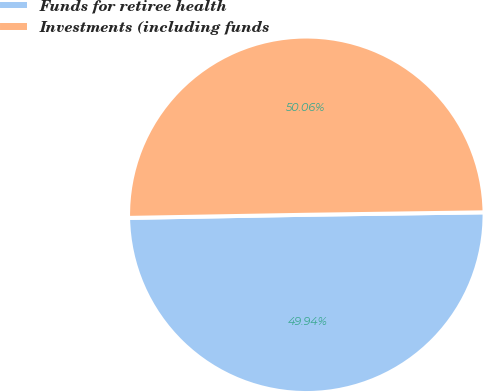<chart> <loc_0><loc_0><loc_500><loc_500><pie_chart><fcel>Funds for retiree health<fcel>Investments (including funds<nl><fcel>49.94%<fcel>50.06%<nl></chart> 